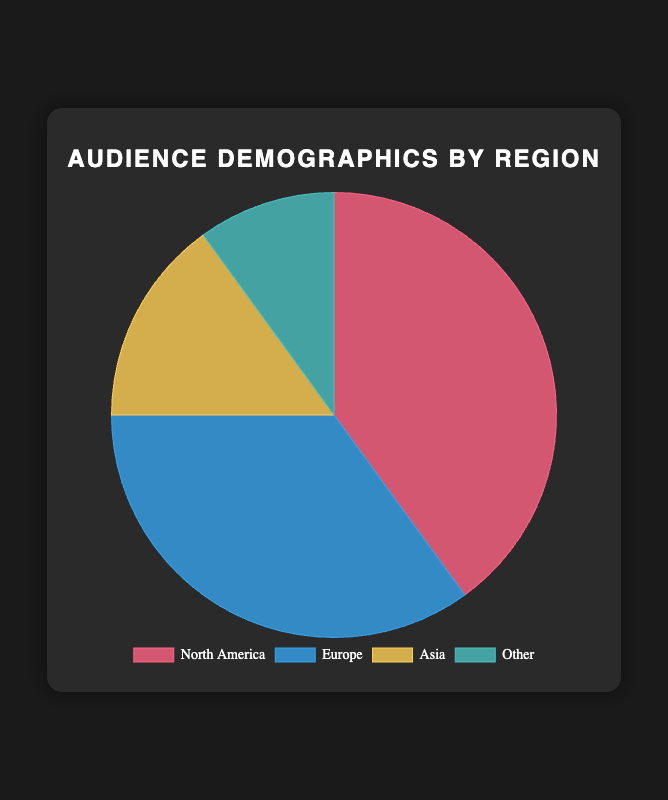What percentage of followers comes from North America and Asia combined? The North America segment is 40% and the Asia segment is 15%. Adding these two percentages together gives 40% + 15% = 55%.
Answer: 55% Which region has the second largest audience percentage? The segments are North America (40%), Europe (35%), Asia (15%), and Other (10%). The second largest percentage is 35%, which corresponds to Europe.
Answer: Europe Are there more followers from Asia or from Other regions? According to the chart, Asia has 15% of the followers while Other regions have 10%. Since 15% is greater than 10%, there are more followers from Asia.
Answer: Asia By how much does the follower percentage of North America exceed that of Europe? North America's follower percentage is 40% and Europe's is 35%. The difference is 40% - 35% = 5%.
Answer: 5% Which region has the smallest percentage of followers and what is that percentage? The regions are North America (40%), Europe (35%), Asia (15%), and Other (10%). The smallest percentage is 10%, which corresponds to Other.
Answer: Other, 10% What is the average percentage of followers in Asia and Europe combined? Asia has 15% and Europe has 35%. The average is calculated as (15% + 35%) / 2 = 50% / 2 = 25%.
Answer: 25% If you sum the followers from Europe and Other regions, how much percentage do they represent together? Europe's percentage is 35% and Other regions' percentage is 10%. Adding these together gives 35% + 10% = 45%.
Answer: 45% What is the difference in audience percentage between the largest and smallest regions? The largest region is North America with 40% and the smallest region is Other with 10%. The difference is 40% - 10% = 30%.
Answer: 30% Which region corresponds to the blue color segment in the pie chart and what is their percentage? According to the provided colors, the blue segment corresponds to Europe. The percentage for Europe is 35%.
Answer: Europe, 35% 